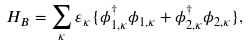<formula> <loc_0><loc_0><loc_500><loc_500>H _ { B } = \sum _ { \kappa } \varepsilon _ { \kappa } \{ \phi _ { 1 , \kappa } ^ { \dagger } \phi _ { 1 , \kappa } + \phi _ { 2 , \kappa } ^ { \dagger } \phi _ { 2 , \kappa } \} ,</formula> 